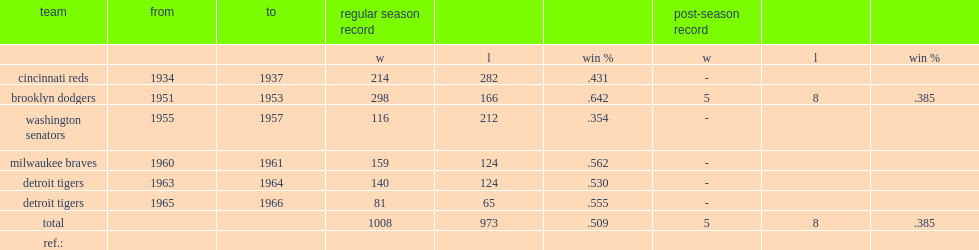How many games did chuck dressen's senators win? 116.0. 